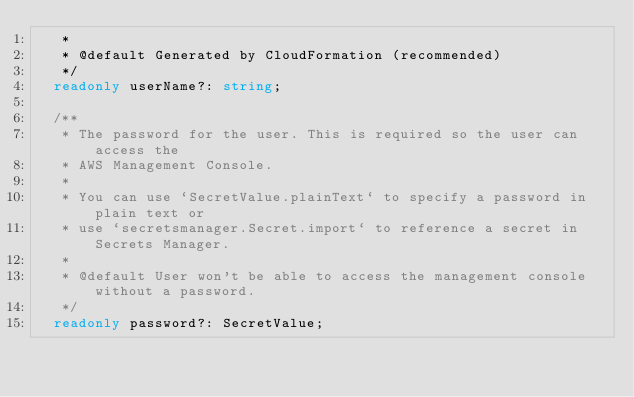<code> <loc_0><loc_0><loc_500><loc_500><_TypeScript_>   *
   * @default Generated by CloudFormation (recommended)
   */
  readonly userName?: string;

  /**
   * The password for the user. This is required so the user can access the
   * AWS Management Console.
   *
   * You can use `SecretValue.plainText` to specify a password in plain text or
   * use `secretsmanager.Secret.import` to reference a secret in Secrets Manager.
   *
   * @default User won't be able to access the management console without a password.
   */
  readonly password?: SecretValue;
</code> 